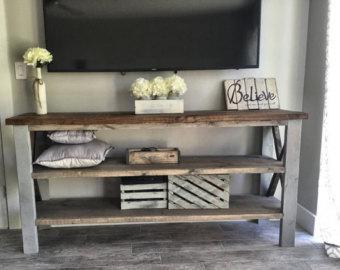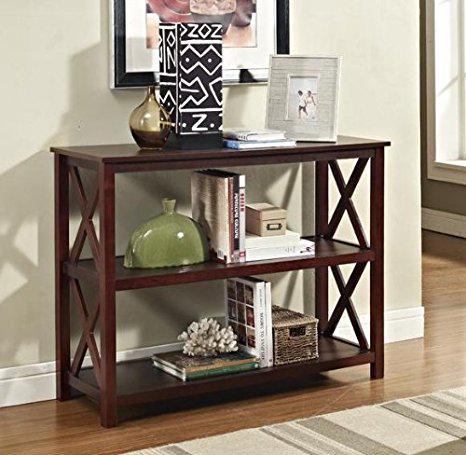The first image is the image on the left, the second image is the image on the right. Considering the images on both sides, is "A TV with a black screen is hanging on a white wall." valid? Answer yes or no. Yes. 